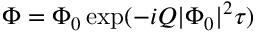Convert formula to latex. <formula><loc_0><loc_0><loc_500><loc_500>\Phi = \Phi _ { 0 } \exp ( - i Q | \Phi _ { 0 } | ^ { 2 } \tau )</formula> 